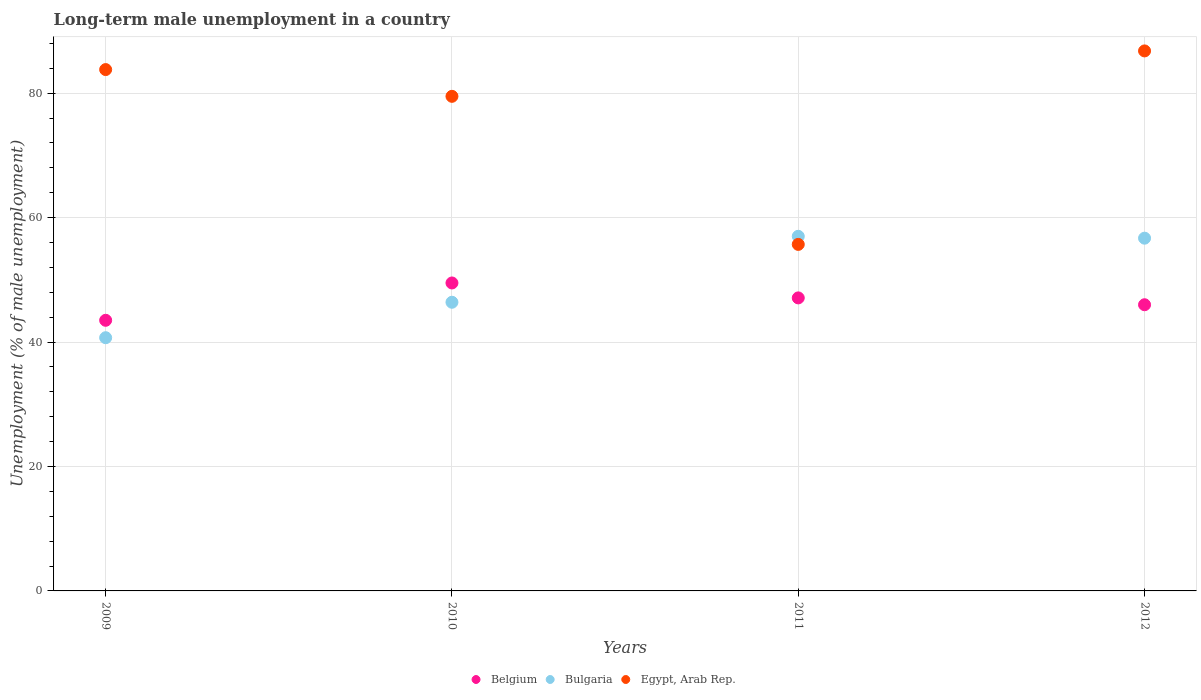What is the percentage of long-term unemployed male population in Bulgaria in 2012?
Give a very brief answer. 56.7. Across all years, what is the maximum percentage of long-term unemployed male population in Belgium?
Offer a very short reply. 49.5. Across all years, what is the minimum percentage of long-term unemployed male population in Belgium?
Provide a short and direct response. 43.5. In which year was the percentage of long-term unemployed male population in Belgium minimum?
Provide a short and direct response. 2009. What is the total percentage of long-term unemployed male population in Belgium in the graph?
Ensure brevity in your answer.  186.1. What is the difference between the percentage of long-term unemployed male population in Egypt, Arab Rep. in 2009 and that in 2011?
Make the answer very short. 28.1. What is the difference between the percentage of long-term unemployed male population in Bulgaria in 2011 and the percentage of long-term unemployed male population in Egypt, Arab Rep. in 2012?
Your response must be concise. -29.8. What is the average percentage of long-term unemployed male population in Belgium per year?
Ensure brevity in your answer.  46.52. In the year 2010, what is the difference between the percentage of long-term unemployed male population in Egypt, Arab Rep. and percentage of long-term unemployed male population in Belgium?
Your answer should be compact. 30. In how many years, is the percentage of long-term unemployed male population in Egypt, Arab Rep. greater than 12 %?
Provide a succinct answer. 4. What is the ratio of the percentage of long-term unemployed male population in Belgium in 2011 to that in 2012?
Offer a very short reply. 1.02. What is the difference between the highest and the second highest percentage of long-term unemployed male population in Bulgaria?
Your answer should be very brief. 0.3. What is the difference between the highest and the lowest percentage of long-term unemployed male population in Bulgaria?
Give a very brief answer. 16.3. In how many years, is the percentage of long-term unemployed male population in Egypt, Arab Rep. greater than the average percentage of long-term unemployed male population in Egypt, Arab Rep. taken over all years?
Keep it short and to the point. 3. Is the percentage of long-term unemployed male population in Belgium strictly less than the percentage of long-term unemployed male population in Bulgaria over the years?
Offer a very short reply. No. How many dotlines are there?
Give a very brief answer. 3. How many years are there in the graph?
Keep it short and to the point. 4. What is the difference between two consecutive major ticks on the Y-axis?
Your response must be concise. 20. Does the graph contain any zero values?
Keep it short and to the point. No. How are the legend labels stacked?
Your answer should be compact. Horizontal. What is the title of the graph?
Keep it short and to the point. Long-term male unemployment in a country. Does "Latin America(developing only)" appear as one of the legend labels in the graph?
Your answer should be very brief. No. What is the label or title of the Y-axis?
Give a very brief answer. Unemployment (% of male unemployment). What is the Unemployment (% of male unemployment) of Belgium in 2009?
Offer a terse response. 43.5. What is the Unemployment (% of male unemployment) in Bulgaria in 2009?
Keep it short and to the point. 40.7. What is the Unemployment (% of male unemployment) of Egypt, Arab Rep. in 2009?
Your response must be concise. 83.8. What is the Unemployment (% of male unemployment) in Belgium in 2010?
Offer a very short reply. 49.5. What is the Unemployment (% of male unemployment) in Bulgaria in 2010?
Your answer should be very brief. 46.4. What is the Unemployment (% of male unemployment) of Egypt, Arab Rep. in 2010?
Your answer should be very brief. 79.5. What is the Unemployment (% of male unemployment) of Belgium in 2011?
Your response must be concise. 47.1. What is the Unemployment (% of male unemployment) in Egypt, Arab Rep. in 2011?
Make the answer very short. 55.7. What is the Unemployment (% of male unemployment) of Bulgaria in 2012?
Make the answer very short. 56.7. What is the Unemployment (% of male unemployment) in Egypt, Arab Rep. in 2012?
Ensure brevity in your answer.  86.8. Across all years, what is the maximum Unemployment (% of male unemployment) of Belgium?
Provide a succinct answer. 49.5. Across all years, what is the maximum Unemployment (% of male unemployment) in Egypt, Arab Rep.?
Give a very brief answer. 86.8. Across all years, what is the minimum Unemployment (% of male unemployment) in Belgium?
Your response must be concise. 43.5. Across all years, what is the minimum Unemployment (% of male unemployment) of Bulgaria?
Your answer should be compact. 40.7. Across all years, what is the minimum Unemployment (% of male unemployment) in Egypt, Arab Rep.?
Give a very brief answer. 55.7. What is the total Unemployment (% of male unemployment) in Belgium in the graph?
Provide a short and direct response. 186.1. What is the total Unemployment (% of male unemployment) in Bulgaria in the graph?
Provide a succinct answer. 200.8. What is the total Unemployment (% of male unemployment) of Egypt, Arab Rep. in the graph?
Give a very brief answer. 305.8. What is the difference between the Unemployment (% of male unemployment) of Bulgaria in 2009 and that in 2010?
Your answer should be compact. -5.7. What is the difference between the Unemployment (% of male unemployment) of Belgium in 2009 and that in 2011?
Provide a succinct answer. -3.6. What is the difference between the Unemployment (% of male unemployment) of Bulgaria in 2009 and that in 2011?
Provide a succinct answer. -16.3. What is the difference between the Unemployment (% of male unemployment) in Egypt, Arab Rep. in 2009 and that in 2011?
Your answer should be very brief. 28.1. What is the difference between the Unemployment (% of male unemployment) of Belgium in 2009 and that in 2012?
Provide a short and direct response. -2.5. What is the difference between the Unemployment (% of male unemployment) of Bulgaria in 2009 and that in 2012?
Give a very brief answer. -16. What is the difference between the Unemployment (% of male unemployment) in Egypt, Arab Rep. in 2009 and that in 2012?
Your answer should be very brief. -3. What is the difference between the Unemployment (% of male unemployment) in Belgium in 2010 and that in 2011?
Your response must be concise. 2.4. What is the difference between the Unemployment (% of male unemployment) of Egypt, Arab Rep. in 2010 and that in 2011?
Offer a terse response. 23.8. What is the difference between the Unemployment (% of male unemployment) in Belgium in 2010 and that in 2012?
Offer a terse response. 3.5. What is the difference between the Unemployment (% of male unemployment) in Egypt, Arab Rep. in 2010 and that in 2012?
Provide a short and direct response. -7.3. What is the difference between the Unemployment (% of male unemployment) of Belgium in 2011 and that in 2012?
Your response must be concise. 1.1. What is the difference between the Unemployment (% of male unemployment) in Egypt, Arab Rep. in 2011 and that in 2012?
Your answer should be compact. -31.1. What is the difference between the Unemployment (% of male unemployment) of Belgium in 2009 and the Unemployment (% of male unemployment) of Bulgaria in 2010?
Provide a short and direct response. -2.9. What is the difference between the Unemployment (% of male unemployment) in Belgium in 2009 and the Unemployment (% of male unemployment) in Egypt, Arab Rep. in 2010?
Your answer should be very brief. -36. What is the difference between the Unemployment (% of male unemployment) of Bulgaria in 2009 and the Unemployment (% of male unemployment) of Egypt, Arab Rep. in 2010?
Offer a terse response. -38.8. What is the difference between the Unemployment (% of male unemployment) in Belgium in 2009 and the Unemployment (% of male unemployment) in Bulgaria in 2011?
Give a very brief answer. -13.5. What is the difference between the Unemployment (% of male unemployment) in Belgium in 2009 and the Unemployment (% of male unemployment) in Egypt, Arab Rep. in 2012?
Offer a very short reply. -43.3. What is the difference between the Unemployment (% of male unemployment) of Bulgaria in 2009 and the Unemployment (% of male unemployment) of Egypt, Arab Rep. in 2012?
Make the answer very short. -46.1. What is the difference between the Unemployment (% of male unemployment) of Belgium in 2010 and the Unemployment (% of male unemployment) of Egypt, Arab Rep. in 2011?
Your answer should be compact. -6.2. What is the difference between the Unemployment (% of male unemployment) of Bulgaria in 2010 and the Unemployment (% of male unemployment) of Egypt, Arab Rep. in 2011?
Make the answer very short. -9.3. What is the difference between the Unemployment (% of male unemployment) in Belgium in 2010 and the Unemployment (% of male unemployment) in Bulgaria in 2012?
Ensure brevity in your answer.  -7.2. What is the difference between the Unemployment (% of male unemployment) of Belgium in 2010 and the Unemployment (% of male unemployment) of Egypt, Arab Rep. in 2012?
Keep it short and to the point. -37.3. What is the difference between the Unemployment (% of male unemployment) of Bulgaria in 2010 and the Unemployment (% of male unemployment) of Egypt, Arab Rep. in 2012?
Your response must be concise. -40.4. What is the difference between the Unemployment (% of male unemployment) in Belgium in 2011 and the Unemployment (% of male unemployment) in Egypt, Arab Rep. in 2012?
Your answer should be very brief. -39.7. What is the difference between the Unemployment (% of male unemployment) of Bulgaria in 2011 and the Unemployment (% of male unemployment) of Egypt, Arab Rep. in 2012?
Make the answer very short. -29.8. What is the average Unemployment (% of male unemployment) of Belgium per year?
Ensure brevity in your answer.  46.52. What is the average Unemployment (% of male unemployment) in Bulgaria per year?
Give a very brief answer. 50.2. What is the average Unemployment (% of male unemployment) in Egypt, Arab Rep. per year?
Keep it short and to the point. 76.45. In the year 2009, what is the difference between the Unemployment (% of male unemployment) of Belgium and Unemployment (% of male unemployment) of Bulgaria?
Your answer should be compact. 2.8. In the year 2009, what is the difference between the Unemployment (% of male unemployment) of Belgium and Unemployment (% of male unemployment) of Egypt, Arab Rep.?
Your answer should be compact. -40.3. In the year 2009, what is the difference between the Unemployment (% of male unemployment) in Bulgaria and Unemployment (% of male unemployment) in Egypt, Arab Rep.?
Your answer should be compact. -43.1. In the year 2010, what is the difference between the Unemployment (% of male unemployment) of Bulgaria and Unemployment (% of male unemployment) of Egypt, Arab Rep.?
Your answer should be very brief. -33.1. In the year 2011, what is the difference between the Unemployment (% of male unemployment) in Belgium and Unemployment (% of male unemployment) in Bulgaria?
Your response must be concise. -9.9. In the year 2011, what is the difference between the Unemployment (% of male unemployment) of Belgium and Unemployment (% of male unemployment) of Egypt, Arab Rep.?
Your answer should be very brief. -8.6. In the year 2012, what is the difference between the Unemployment (% of male unemployment) of Belgium and Unemployment (% of male unemployment) of Bulgaria?
Offer a terse response. -10.7. In the year 2012, what is the difference between the Unemployment (% of male unemployment) of Belgium and Unemployment (% of male unemployment) of Egypt, Arab Rep.?
Ensure brevity in your answer.  -40.8. In the year 2012, what is the difference between the Unemployment (% of male unemployment) of Bulgaria and Unemployment (% of male unemployment) of Egypt, Arab Rep.?
Provide a short and direct response. -30.1. What is the ratio of the Unemployment (% of male unemployment) in Belgium in 2009 to that in 2010?
Your response must be concise. 0.88. What is the ratio of the Unemployment (% of male unemployment) in Bulgaria in 2009 to that in 2010?
Give a very brief answer. 0.88. What is the ratio of the Unemployment (% of male unemployment) of Egypt, Arab Rep. in 2009 to that in 2010?
Ensure brevity in your answer.  1.05. What is the ratio of the Unemployment (% of male unemployment) of Belgium in 2009 to that in 2011?
Your answer should be compact. 0.92. What is the ratio of the Unemployment (% of male unemployment) of Bulgaria in 2009 to that in 2011?
Ensure brevity in your answer.  0.71. What is the ratio of the Unemployment (% of male unemployment) in Egypt, Arab Rep. in 2009 to that in 2011?
Your answer should be compact. 1.5. What is the ratio of the Unemployment (% of male unemployment) of Belgium in 2009 to that in 2012?
Ensure brevity in your answer.  0.95. What is the ratio of the Unemployment (% of male unemployment) in Bulgaria in 2009 to that in 2012?
Make the answer very short. 0.72. What is the ratio of the Unemployment (% of male unemployment) of Egypt, Arab Rep. in 2009 to that in 2012?
Your response must be concise. 0.97. What is the ratio of the Unemployment (% of male unemployment) in Belgium in 2010 to that in 2011?
Make the answer very short. 1.05. What is the ratio of the Unemployment (% of male unemployment) of Bulgaria in 2010 to that in 2011?
Ensure brevity in your answer.  0.81. What is the ratio of the Unemployment (% of male unemployment) of Egypt, Arab Rep. in 2010 to that in 2011?
Keep it short and to the point. 1.43. What is the ratio of the Unemployment (% of male unemployment) in Belgium in 2010 to that in 2012?
Provide a short and direct response. 1.08. What is the ratio of the Unemployment (% of male unemployment) in Bulgaria in 2010 to that in 2012?
Your response must be concise. 0.82. What is the ratio of the Unemployment (% of male unemployment) of Egypt, Arab Rep. in 2010 to that in 2012?
Your answer should be very brief. 0.92. What is the ratio of the Unemployment (% of male unemployment) of Belgium in 2011 to that in 2012?
Provide a short and direct response. 1.02. What is the ratio of the Unemployment (% of male unemployment) of Egypt, Arab Rep. in 2011 to that in 2012?
Offer a terse response. 0.64. What is the difference between the highest and the second highest Unemployment (% of male unemployment) of Bulgaria?
Provide a succinct answer. 0.3. What is the difference between the highest and the second highest Unemployment (% of male unemployment) of Egypt, Arab Rep.?
Ensure brevity in your answer.  3. What is the difference between the highest and the lowest Unemployment (% of male unemployment) of Bulgaria?
Your response must be concise. 16.3. What is the difference between the highest and the lowest Unemployment (% of male unemployment) of Egypt, Arab Rep.?
Your response must be concise. 31.1. 